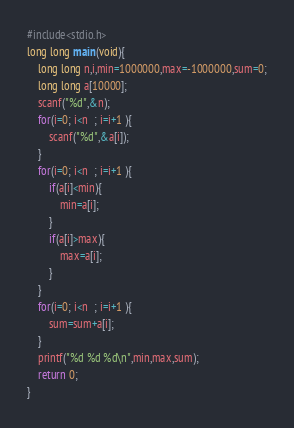<code> <loc_0><loc_0><loc_500><loc_500><_C_>#include<stdio.h>
long long main(void){
	long long n,i,min=1000000,max=-1000000,sum=0;
	long long a[10000];
	scanf("%d",&n);
	for(i=0; i<n  ; i=i+1 ){
		scanf("%d",&a[i]);
	}
	for(i=0; i<n  ; i=i+1 ){
		if(a[i]<min){
			min=a[i];
		}
		if(a[i]>max){
			max=a[i];
		}
	}
	for(i=0; i<n  ; i=i+1 ){
		sum=sum+a[i];
	}
	printf("%d %d %d\n",min,max,sum);
	return 0;
}</code> 